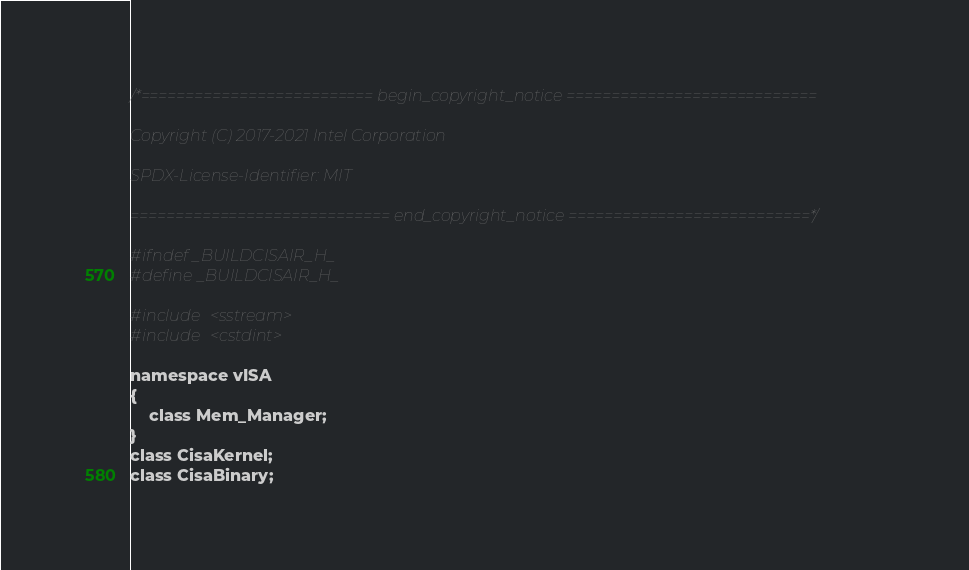Convert code to text. <code><loc_0><loc_0><loc_500><loc_500><_C_>/*========================== begin_copyright_notice ============================

Copyright (C) 2017-2021 Intel Corporation

SPDX-License-Identifier: MIT

============================= end_copyright_notice ===========================*/

#ifndef _BUILDCISAIR_H_
#define _BUILDCISAIR_H_

#include <sstream>
#include <cstdint>

namespace vISA
{
    class Mem_Manager;
}
class CisaKernel;
class CisaBinary;</code> 